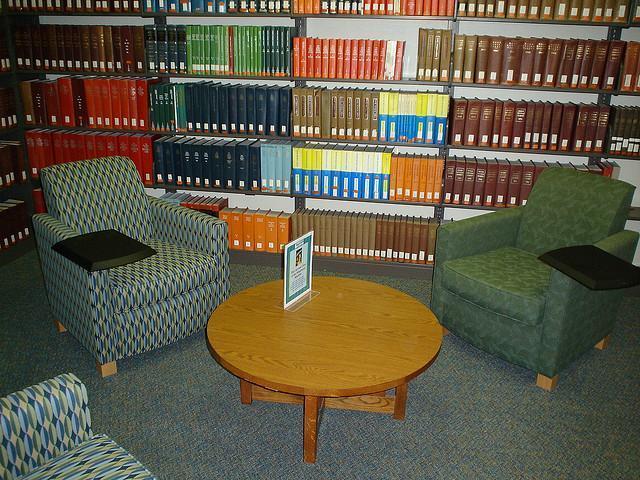How many chairs are there?
Give a very brief answer. 3. How many couches are there?
Give a very brief answer. 2. How many books can you see?
Give a very brief answer. 2. 